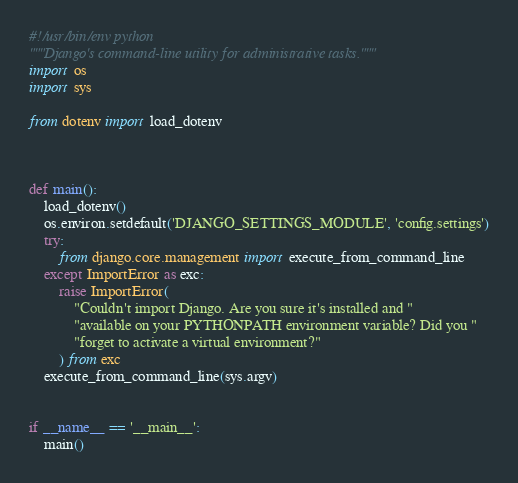<code> <loc_0><loc_0><loc_500><loc_500><_Python_>#!/usr/bin/env python
"""Django's command-line utility for administrative tasks."""
import os
import sys

from dotenv import load_dotenv



def main():
    load_dotenv()
    os.environ.setdefault('DJANGO_SETTINGS_MODULE', 'config.settings')
    try:
        from django.core.management import execute_from_command_line
    except ImportError as exc:
        raise ImportError(
            "Couldn't import Django. Are you sure it's installed and "
            "available on your PYTHONPATH environment variable? Did you "
            "forget to activate a virtual environment?"
        ) from exc
    execute_from_command_line(sys.argv)


if __name__ == '__main__':
    main()
</code> 